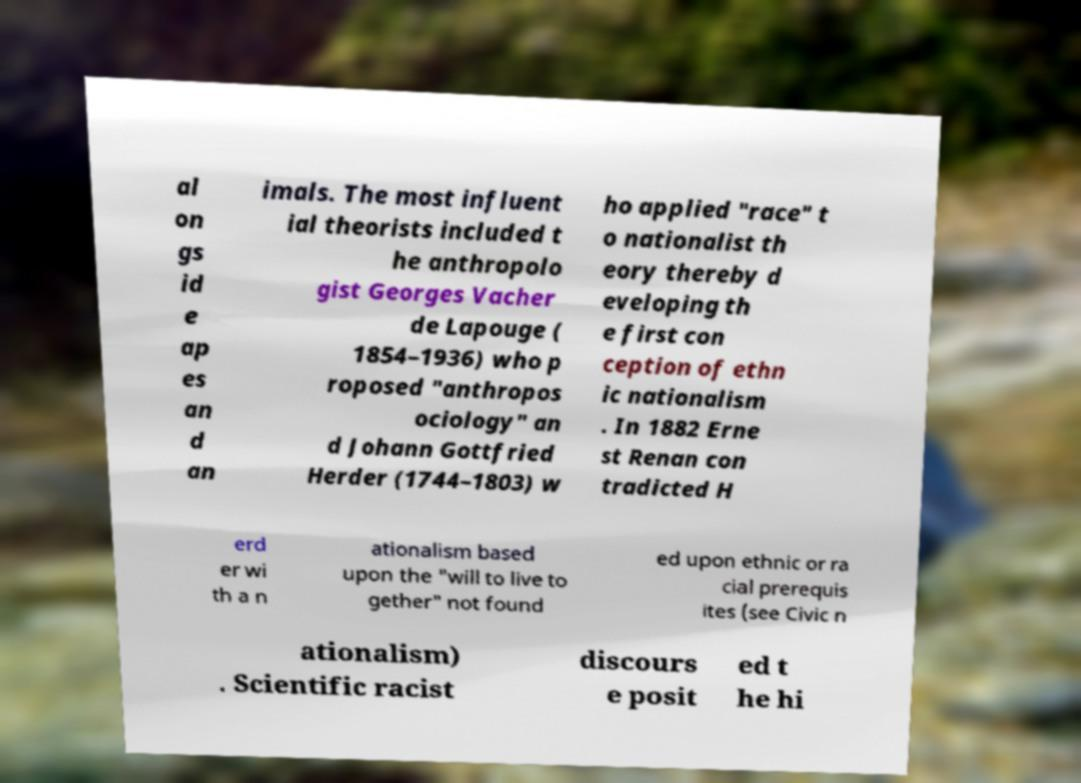What messages or text are displayed in this image? I need them in a readable, typed format. al on gs id e ap es an d an imals. The most influent ial theorists included t he anthropolo gist Georges Vacher de Lapouge ( 1854–1936) who p roposed "anthropos ociology" an d Johann Gottfried Herder (1744–1803) w ho applied "race" t o nationalist th eory thereby d eveloping th e first con ception of ethn ic nationalism . In 1882 Erne st Renan con tradicted H erd er wi th a n ationalism based upon the "will to live to gether" not found ed upon ethnic or ra cial prerequis ites (see Civic n ationalism) . Scientific racist discours e posit ed t he hi 